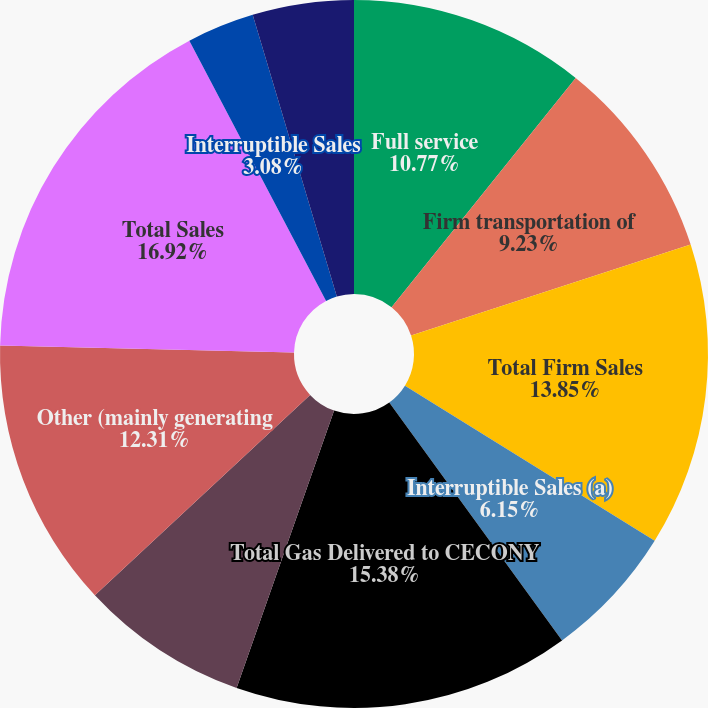Convert chart to OTSL. <chart><loc_0><loc_0><loc_500><loc_500><pie_chart><fcel>Full service<fcel>Firm transportation of<fcel>Total Firm Sales<fcel>Interruptible Sales (a)<fcel>Total Gas Delivered to CECONY<fcel>NYPA<fcel>Other (mainly generating<fcel>Total Sales<fcel>Interruptible Sales<fcel>Other operating revenues<nl><fcel>10.77%<fcel>9.23%<fcel>13.85%<fcel>6.15%<fcel>15.38%<fcel>7.69%<fcel>12.31%<fcel>16.92%<fcel>3.08%<fcel>4.62%<nl></chart> 